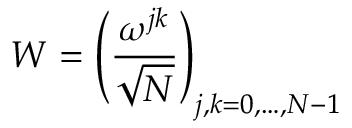<formula> <loc_0><loc_0><loc_500><loc_500>W = \left ( { \frac { \omega ^ { j k } } { \sqrt { N } } } \right ) _ { j , k = 0 , \dots , N - 1 }</formula> 